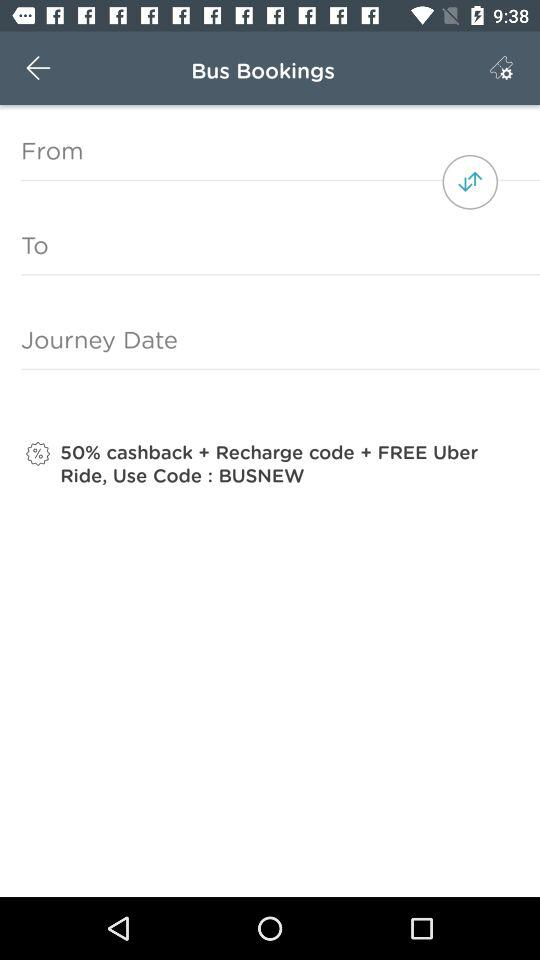What code do I have to use to get 50% cashback? You have to use the code "BUSNEW" to get 50% cashback. 